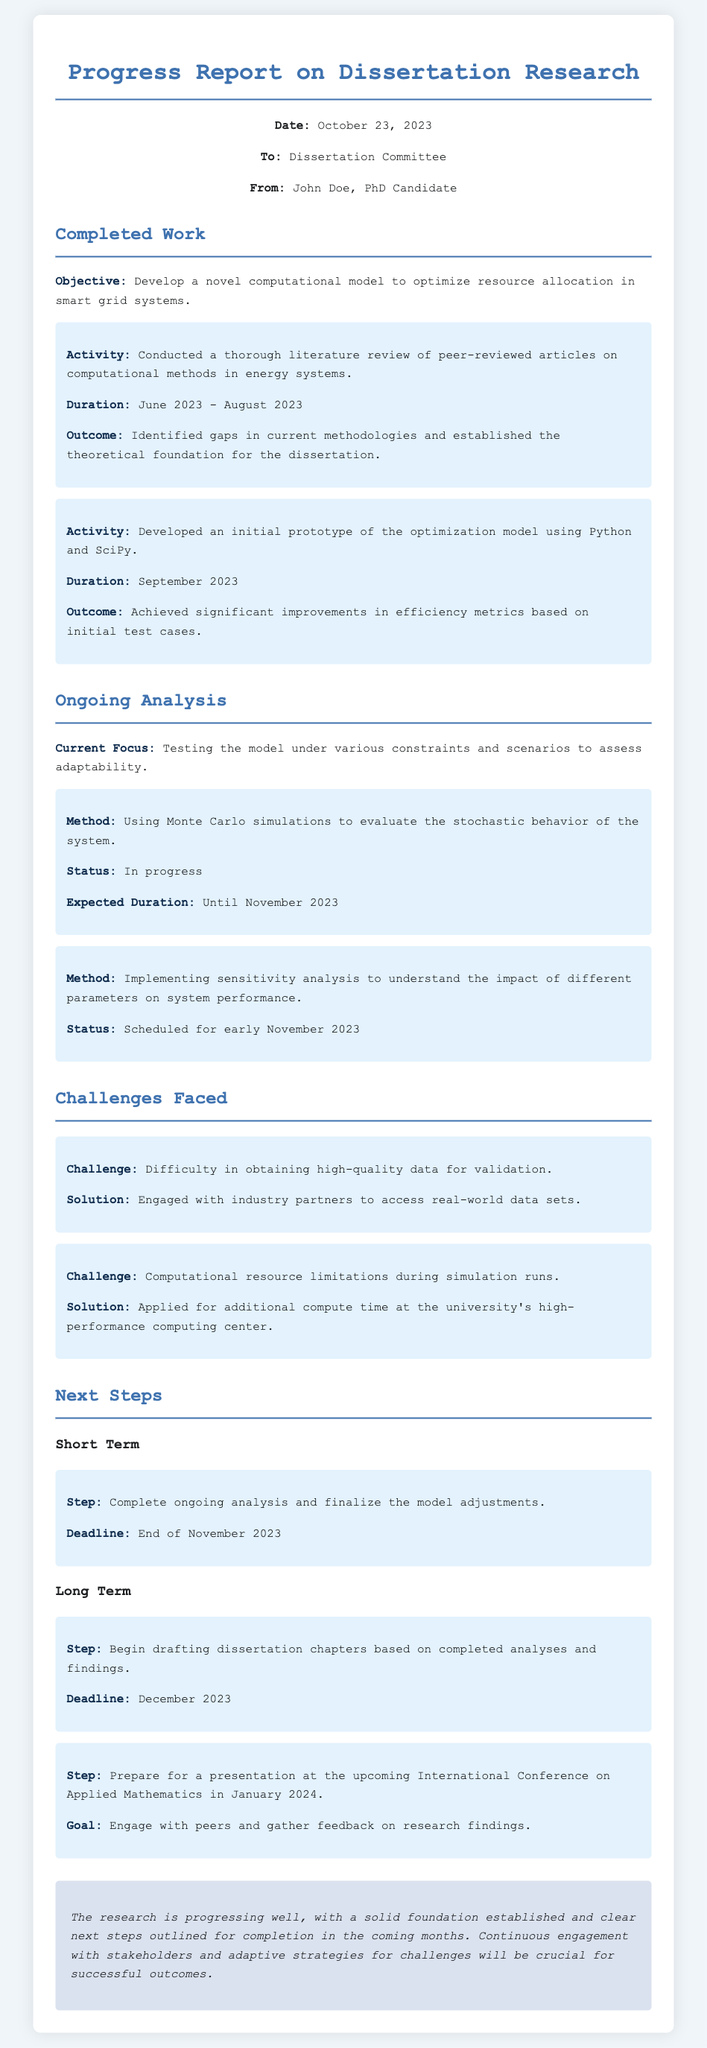What is the dissertation title? The dissertation title is provided in the objective section, which highlights the focus on developing a computational model for resource allocation in smart grid systems.
Answer: Optimization of resource allocation in smart grid systems What is the duration of the literature review? The duration of the literature review is specified in the completed work section, detailing the timeline of the activity.
Answer: June 2023 - August 2023 What is the method currently being used for ongoing analysis? The document outlines the current focus on testing the model, mentioning Monte Carlo simulations for analysis within the ongoing section.
Answer: Monte Carlo simulations What challenge is related to data validation? The challenge section indicates specific issues faced during the research, with a particular mention of validation difficulties.
Answer: Difficulty in obtaining high-quality data for validation What is the next step for the end of November 2023? The next step outlined includes completing ongoing analysis and finalizing model adjustments, with a clear deadline provided within the next steps section.
Answer: Complete ongoing analysis and finalize the model adjustments How long is the total expected duration for the ongoing analysis? The ongoing analysis has an expected duration mentioned in the document, which indicates the time frame from the current focus until completion.
Answer: Until November 2023 What is the goal of the upcoming presentation in January 2024? The document specifies objectives related to the presentation, indicating the purpose of engaging with peers and gathering feedback.
Answer: Engage with peers and gather feedback on research findings 